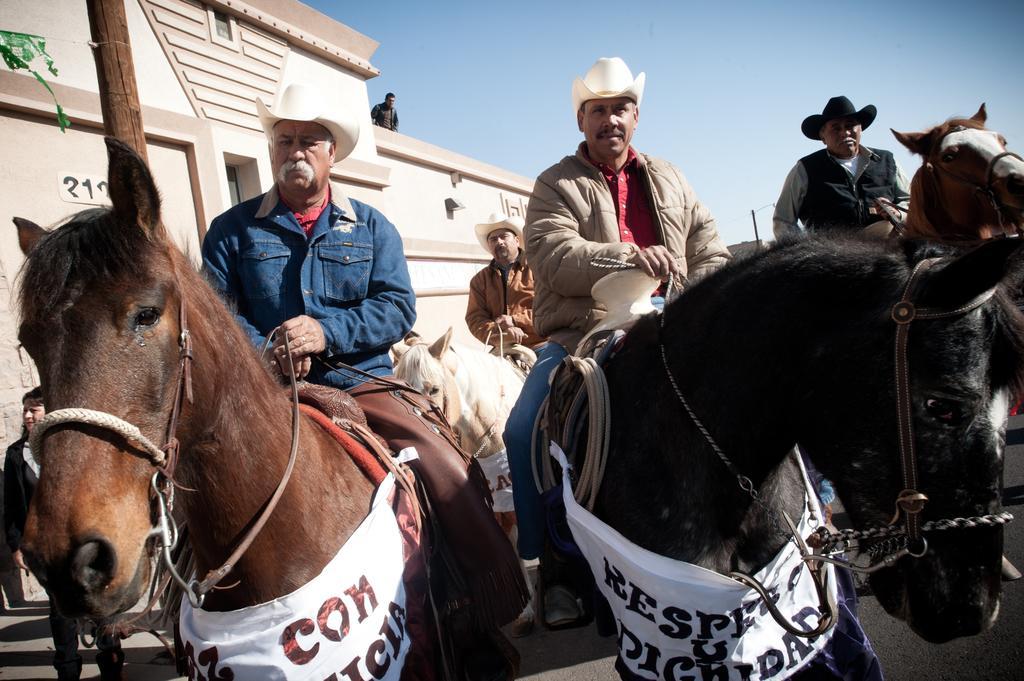Could you give a brief overview of what you see in this image? This picture describes about group of people some people are riding the horses, in the background we can see house. 